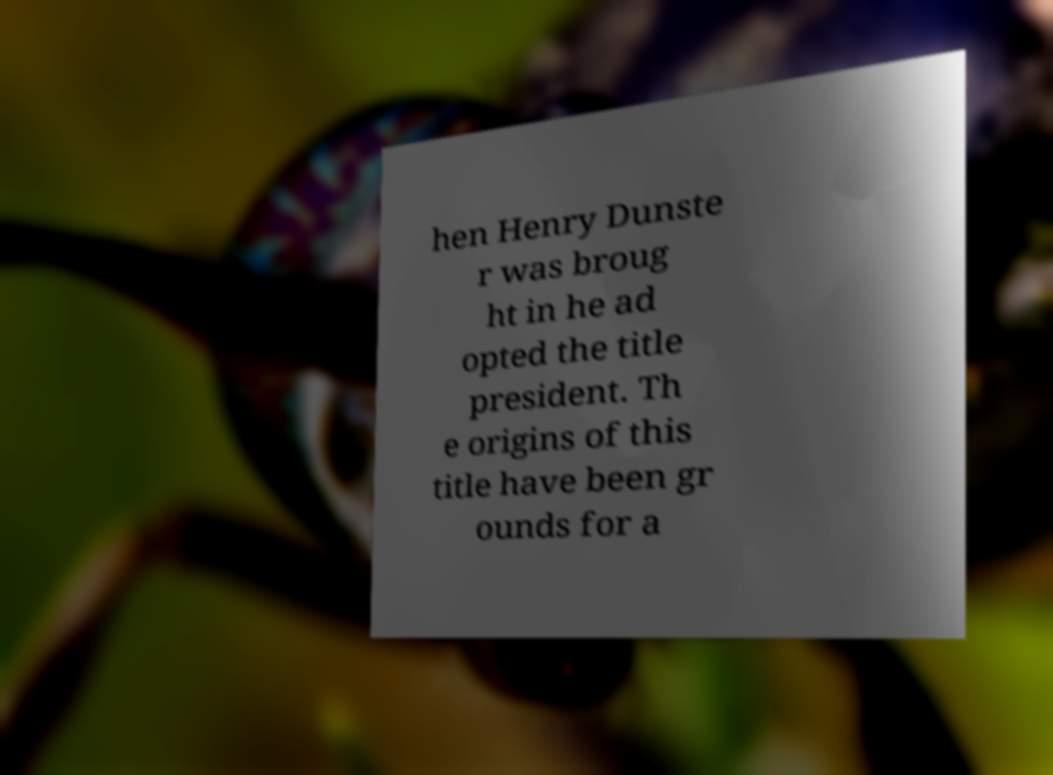Could you assist in decoding the text presented in this image and type it out clearly? hen Henry Dunste r was broug ht in he ad opted the title president. Th e origins of this title have been gr ounds for a 